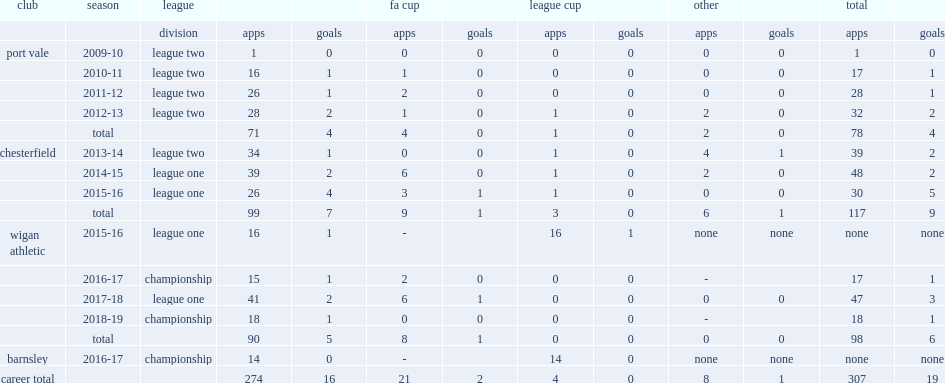In 2014-15, which league did sam morsy play for chesterfield in? League one. 